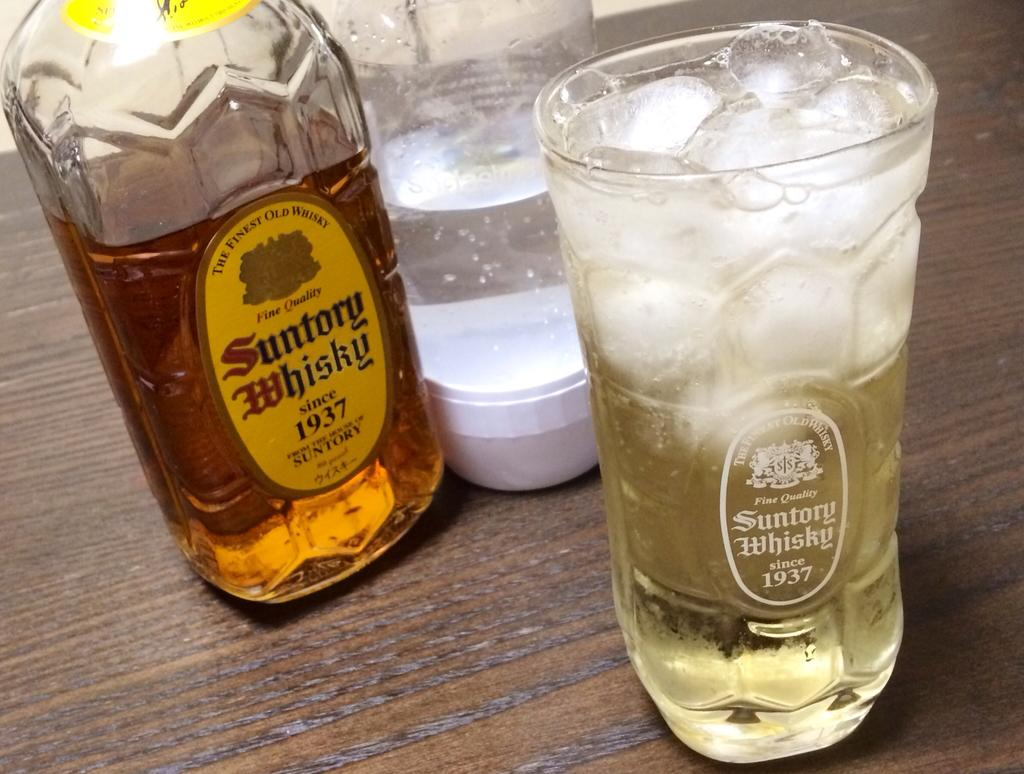<image>
Give a short and clear explanation of the subsequent image. A bottle and glass of Suntory Whiskey labeled 1937. 